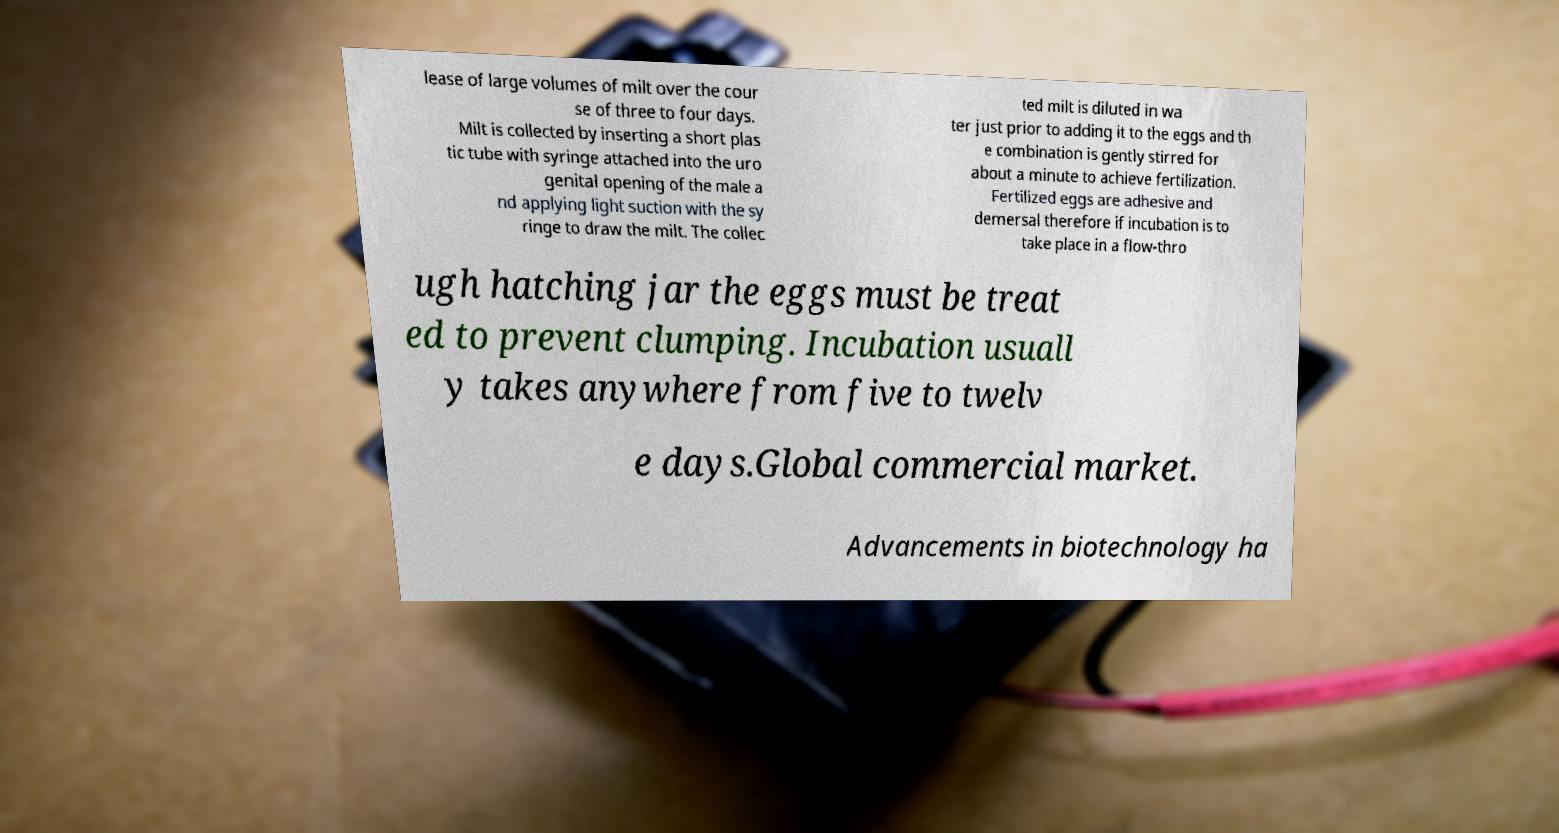Please read and relay the text visible in this image. What does it say? lease of large volumes of milt over the cour se of three to four days. Milt is collected by inserting a short plas tic tube with syringe attached into the uro genital opening of the male a nd applying light suction with the sy ringe to draw the milt. The collec ted milt is diluted in wa ter just prior to adding it to the eggs and th e combination is gently stirred for about a minute to achieve fertilization. Fertilized eggs are adhesive and demersal therefore if incubation is to take place in a flow-thro ugh hatching jar the eggs must be treat ed to prevent clumping. Incubation usuall y takes anywhere from five to twelv e days.Global commercial market. Advancements in biotechnology ha 